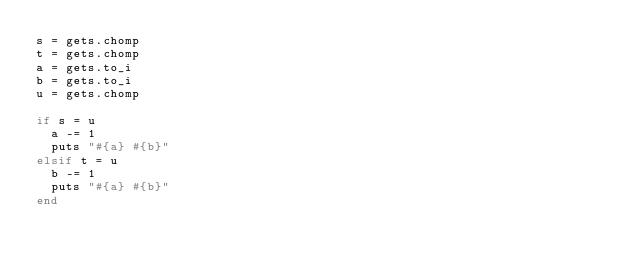Convert code to text. <code><loc_0><loc_0><loc_500><loc_500><_Ruby_>s = gets.chomp
t = gets.chomp
a = gets.to_i
b = gets.to_i
u = gets.chomp

if s = u
  a -= 1
  puts "#{a} #{b}"
elsif t = u
  b -= 1
  puts "#{a} #{b}"
end
</code> 